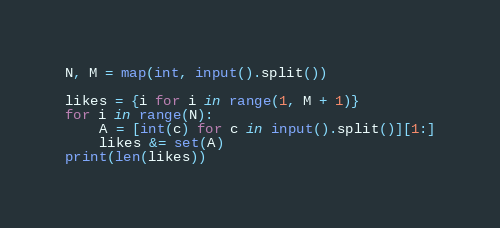<code> <loc_0><loc_0><loc_500><loc_500><_Python_>N, M = map(int, input().split())

likes = {i for i in range(1, M + 1)}
for i in range(N):
    A = [int(c) for c in input().split()][1:]
    likes &= set(A)
print(len(likes))
</code> 